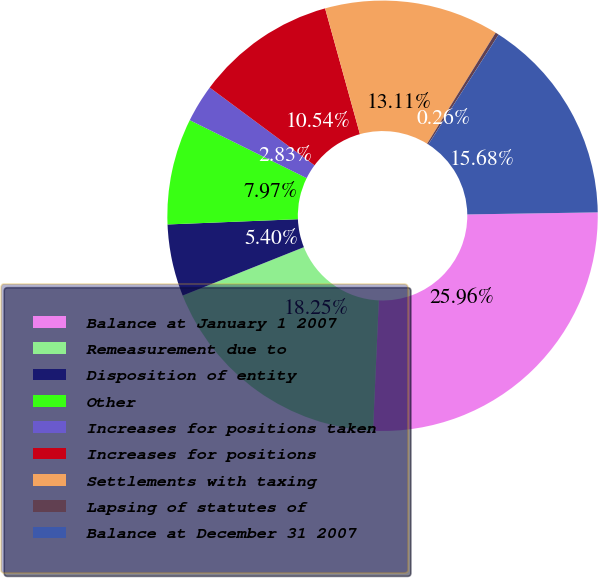<chart> <loc_0><loc_0><loc_500><loc_500><pie_chart><fcel>Balance at January 1 2007<fcel>Remeasurement due to<fcel>Disposition of entity<fcel>Other<fcel>Increases for positions taken<fcel>Increases for positions<fcel>Settlements with taxing<fcel>Lapsing of statutes of<fcel>Balance at December 31 2007<nl><fcel>25.96%<fcel>18.25%<fcel>5.4%<fcel>7.97%<fcel>2.83%<fcel>10.54%<fcel>13.11%<fcel>0.26%<fcel>15.68%<nl></chart> 